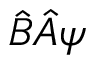Convert formula to latex. <formula><loc_0><loc_0><loc_500><loc_500>{ \hat { B } } { \hat { A } } \psi</formula> 